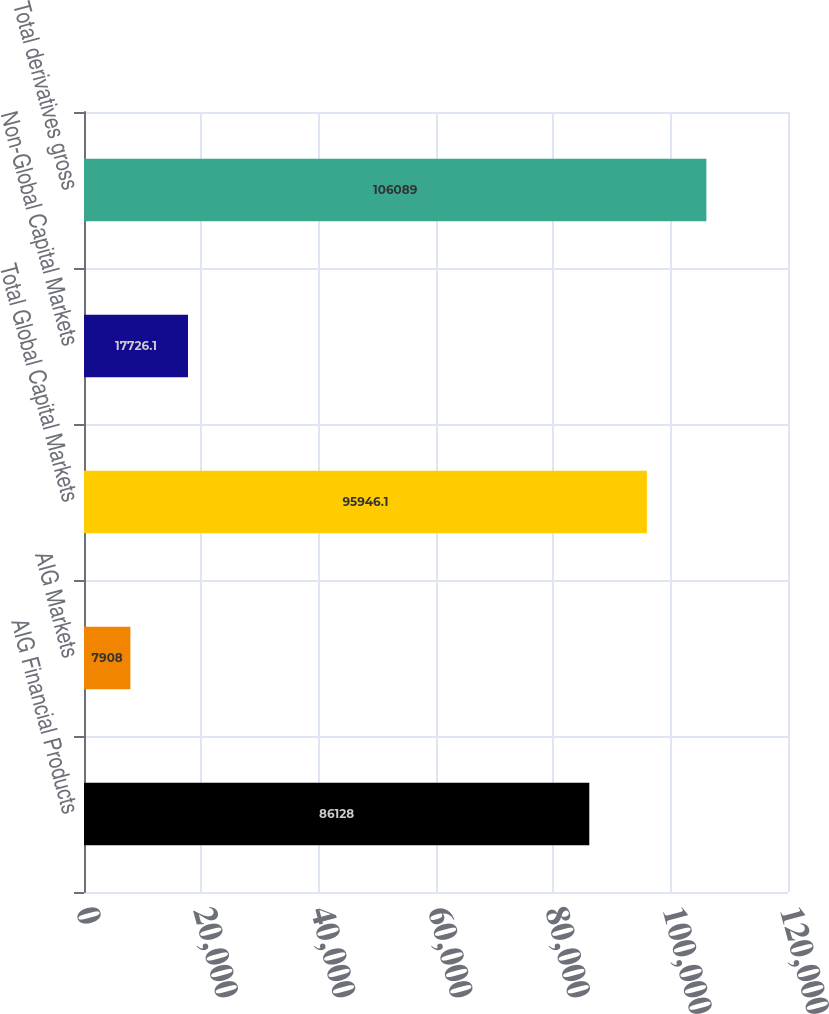Convert chart to OTSL. <chart><loc_0><loc_0><loc_500><loc_500><bar_chart><fcel>AIG Financial Products<fcel>AIG Markets<fcel>Total Global Capital Markets<fcel>Non-Global Capital Markets<fcel>Total derivatives gross<nl><fcel>86128<fcel>7908<fcel>95946.1<fcel>17726.1<fcel>106089<nl></chart> 